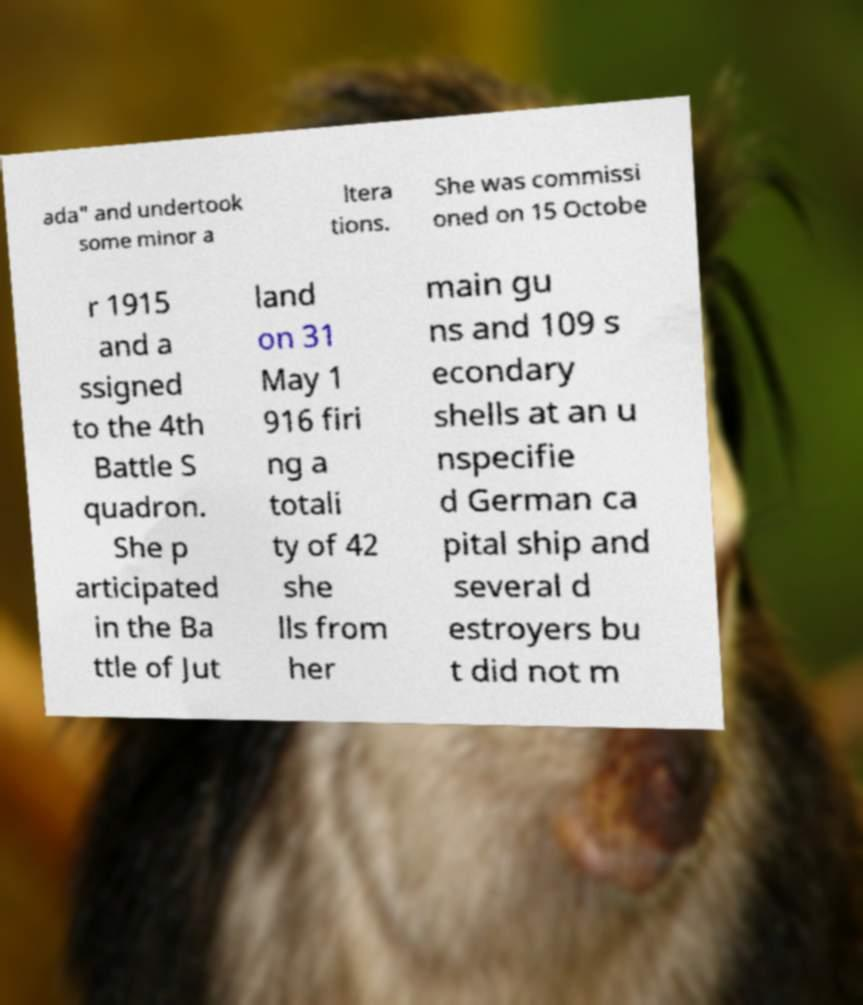I need the written content from this picture converted into text. Can you do that? ada" and undertook some minor a ltera tions. She was commissi oned on 15 Octobe r 1915 and a ssigned to the 4th Battle S quadron. She p articipated in the Ba ttle of Jut land on 31 May 1 916 firi ng a totali ty of 42 she lls from her main gu ns and 109 s econdary shells at an u nspecifie d German ca pital ship and several d estroyers bu t did not m 